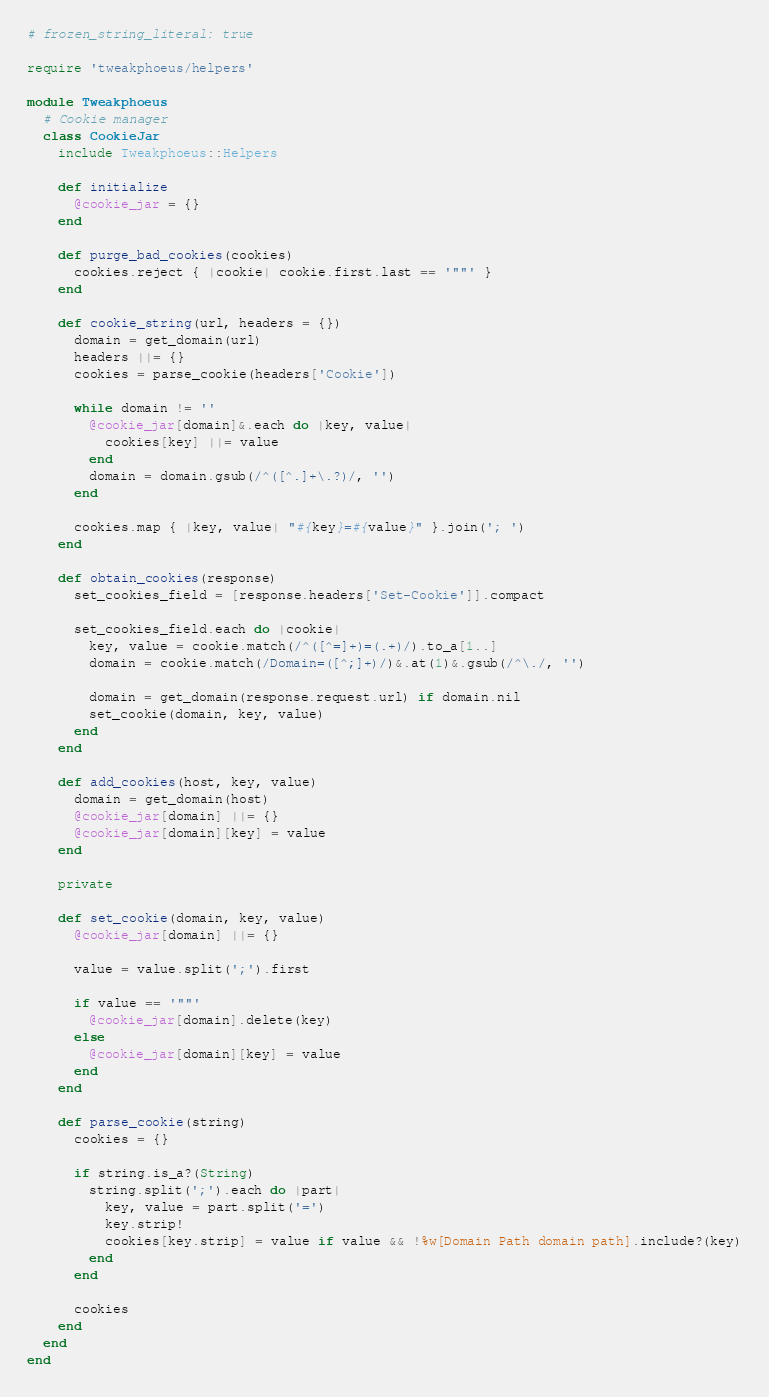<code> <loc_0><loc_0><loc_500><loc_500><_Ruby_># frozen_string_literal: true

require 'tweakphoeus/helpers'

module Tweakphoeus
  # Cookie manager
  class CookieJar
    include Tweakphoeus::Helpers

    def initialize
      @cookie_jar = {}
    end

    def purge_bad_cookies(cookies)
      cookies.reject { |cookie| cookie.first.last == '""' }
    end

    def cookie_string(url, headers = {})
      domain = get_domain(url)
      headers ||= {}
      cookies = parse_cookie(headers['Cookie'])

      while domain != ''
        @cookie_jar[domain]&.each do |key, value|
          cookies[key] ||= value
        end
        domain = domain.gsub(/^([^.]+\.?)/, '')
      end

      cookies.map { |key, value| "#{key}=#{value}" }.join('; ')
    end

    def obtain_cookies(response)
      set_cookies_field = [response.headers['Set-Cookie']].compact

      set_cookies_field.each do |cookie|
        key, value = cookie.match(/^([^=]+)=(.+)/).to_a[1..]
        domain = cookie.match(/Domain=([^;]+)/)&.at(1)&.gsub(/^\./, '')

        domain = get_domain(response.request.url) if domain.nil
        set_cookie(domain, key, value)
      end
    end

    def add_cookies(host, key, value)
      domain = get_domain(host)
      @cookie_jar[domain] ||= {}
      @cookie_jar[domain][key] = value
    end

    private

    def set_cookie(domain, key, value)
      @cookie_jar[domain] ||= {}

      value = value.split(';').first

      if value == '""'
        @cookie_jar[domain].delete(key)
      else
        @cookie_jar[domain][key] = value
      end
    end

    def parse_cookie(string)
      cookies = {}

      if string.is_a?(String)
        string.split(';').each do |part|
          key, value = part.split('=')
          key.strip!
          cookies[key.strip] = value if value && !%w[Domain Path domain path].include?(key)
        end
      end

      cookies
    end
  end
end
</code> 